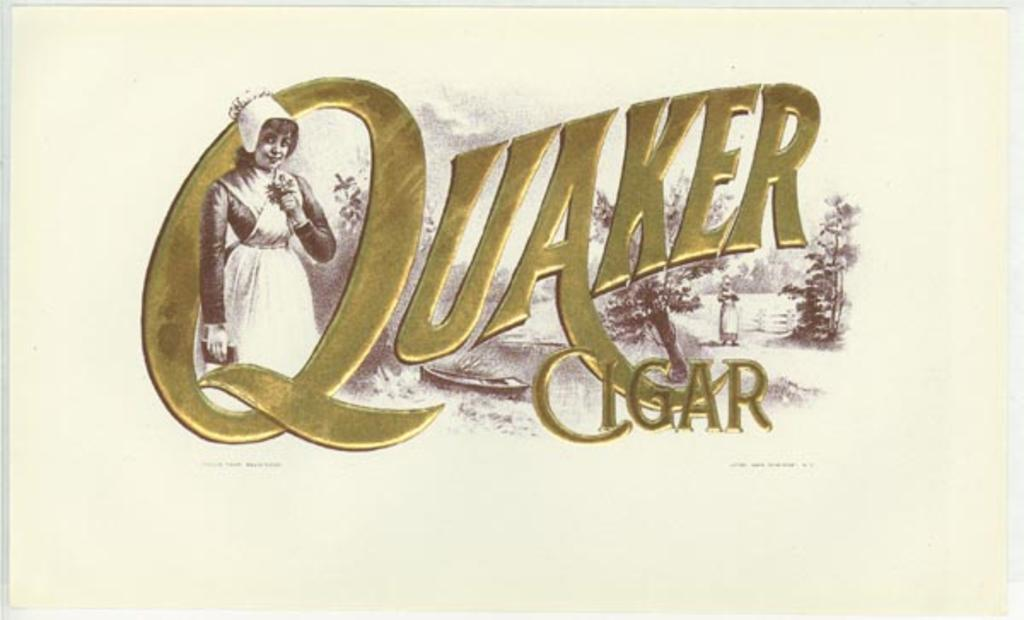What is featured on the poster in the image? There is a poster in the image, and it contains a picture of a woman. What is the woman in the picture doing? The woman in the picture is standing. What can be observed about the woman's attire in the picture? The woman in the picture is wearing clothes. What is the woman's facial expression in the picture? The woman in the picture is smiling. What else is present on the poster besides the picture of the woman? There is text on the poster. Can you tell me how many kites are being flown by the mice in the image? There are no mice or kites present in the image; it features a poster with a picture of a woman. What type of van is parked next to the poster in the image? There is no van present in the image; it only contains a poster with a picture of a woman. 